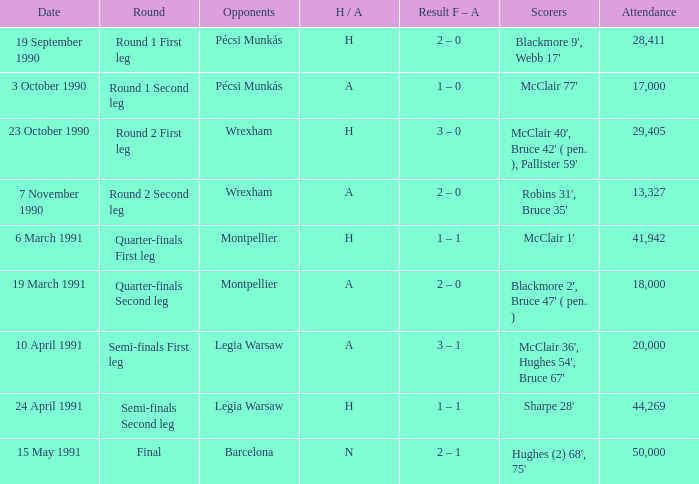What is the smallest attendance when the h/a is h in the semi-finals second leg? 44269.0. 